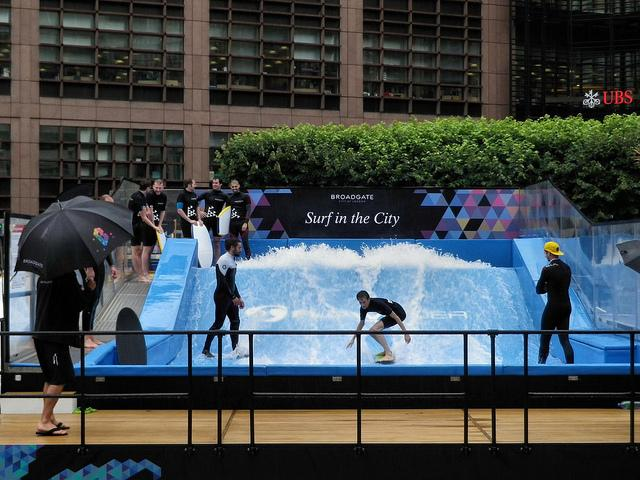What sort of building is seen behind this amusement? office 